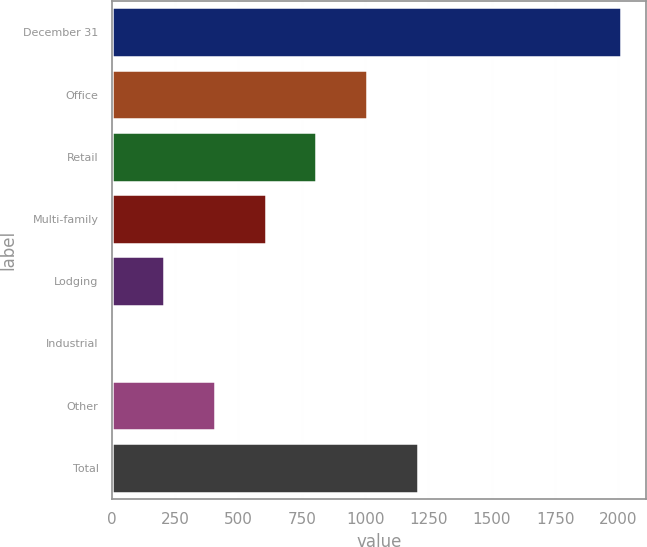<chart> <loc_0><loc_0><loc_500><loc_500><bar_chart><fcel>December 31<fcel>Office<fcel>Retail<fcel>Multi-family<fcel>Lodging<fcel>Industrial<fcel>Other<fcel>Total<nl><fcel>2010<fcel>1008<fcel>807.6<fcel>607.2<fcel>206.4<fcel>6<fcel>406.8<fcel>1208.4<nl></chart> 